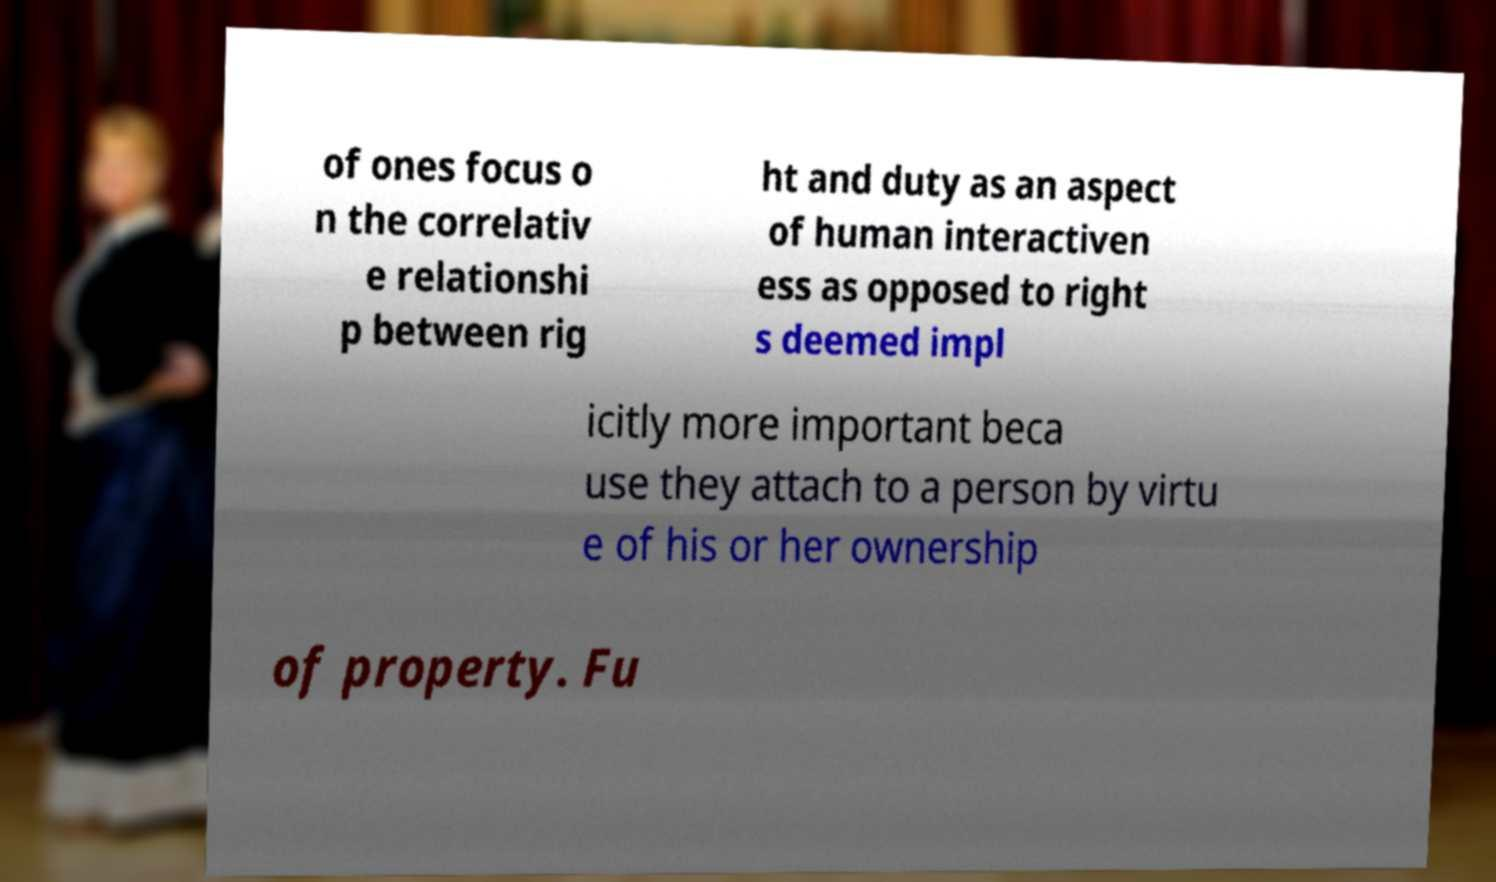Could you assist in decoding the text presented in this image and type it out clearly? of ones focus o n the correlativ e relationshi p between rig ht and duty as an aspect of human interactiven ess as opposed to right s deemed impl icitly more important beca use they attach to a person by virtu e of his or her ownership of property. Fu 